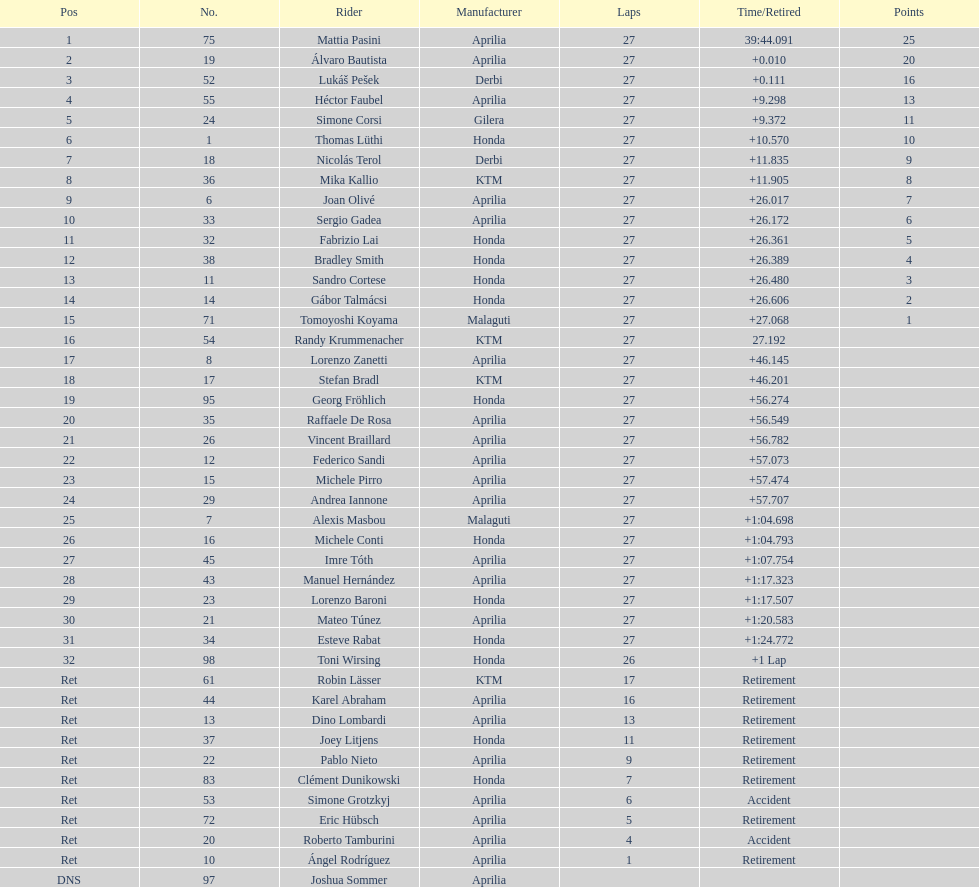How many german racers finished the race? 4. 